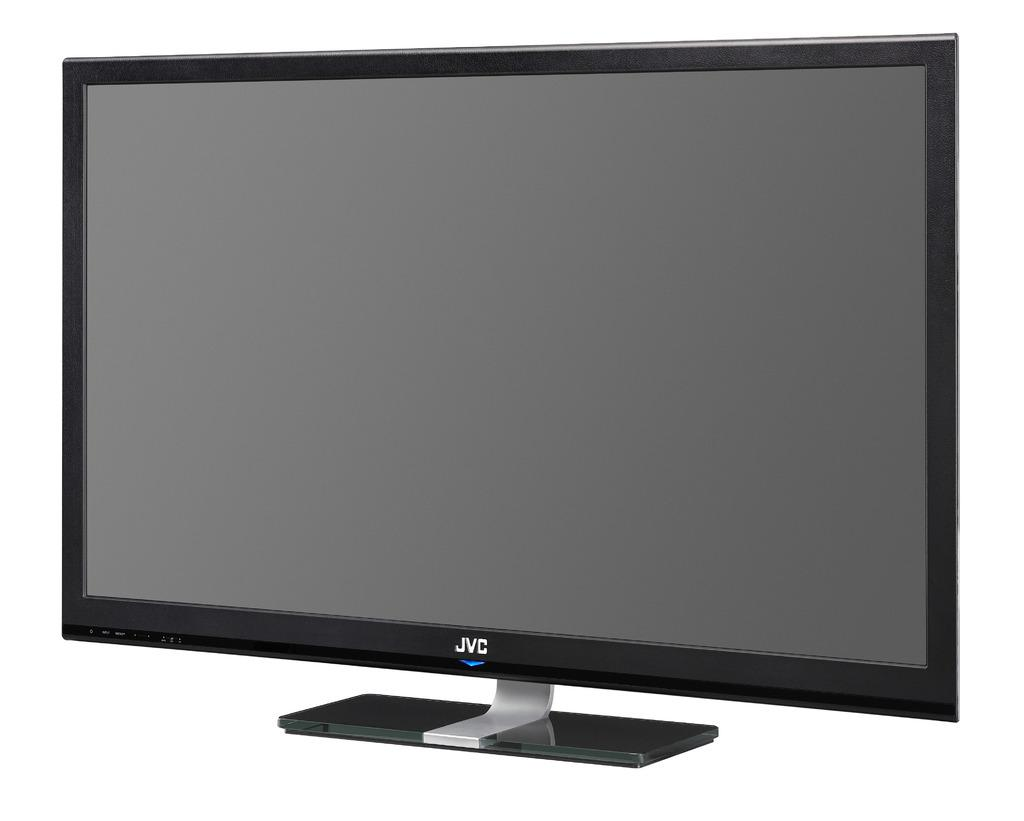<image>
Share a concise interpretation of the image provided. A JVC flat screen TV is against a white background. 